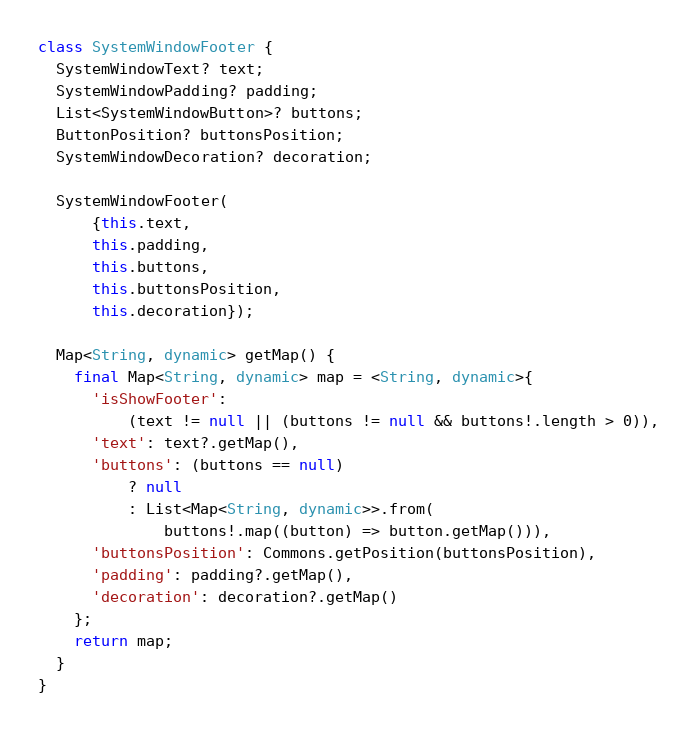<code> <loc_0><loc_0><loc_500><loc_500><_Dart_>class SystemWindowFooter {
  SystemWindowText? text;
  SystemWindowPadding? padding;
  List<SystemWindowButton>? buttons;
  ButtonPosition? buttonsPosition;
  SystemWindowDecoration? decoration;

  SystemWindowFooter(
      {this.text,
      this.padding,
      this.buttons,
      this.buttonsPosition,
      this.decoration});

  Map<String, dynamic> getMap() {
    final Map<String, dynamic> map = <String, dynamic>{
      'isShowFooter':
          (text != null || (buttons != null && buttons!.length > 0)),
      'text': text?.getMap(),
      'buttons': (buttons == null)
          ? null
          : List<Map<String, dynamic>>.from(
              buttons!.map((button) => button.getMap())),
      'buttonsPosition': Commons.getPosition(buttonsPosition),
      'padding': padding?.getMap(),
      'decoration': decoration?.getMap()
    };
    return map;
  }
}
</code> 